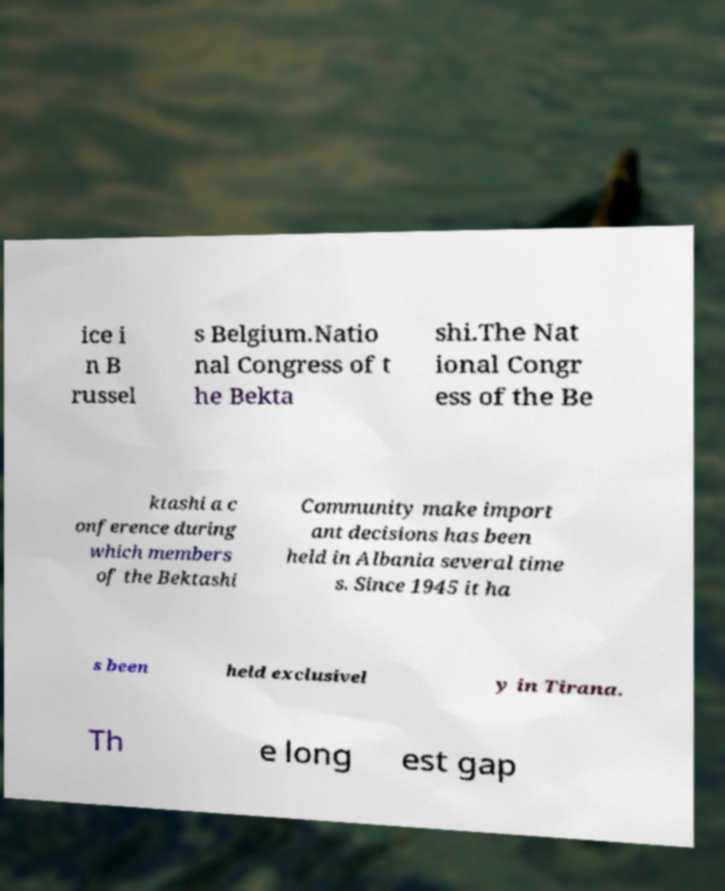Could you extract and type out the text from this image? ice i n B russel s Belgium.Natio nal Congress of t he Bekta shi.The Nat ional Congr ess of the Be ktashi a c onference during which members of the Bektashi Community make import ant decisions has been held in Albania several time s. Since 1945 it ha s been held exclusivel y in Tirana. Th e long est gap 